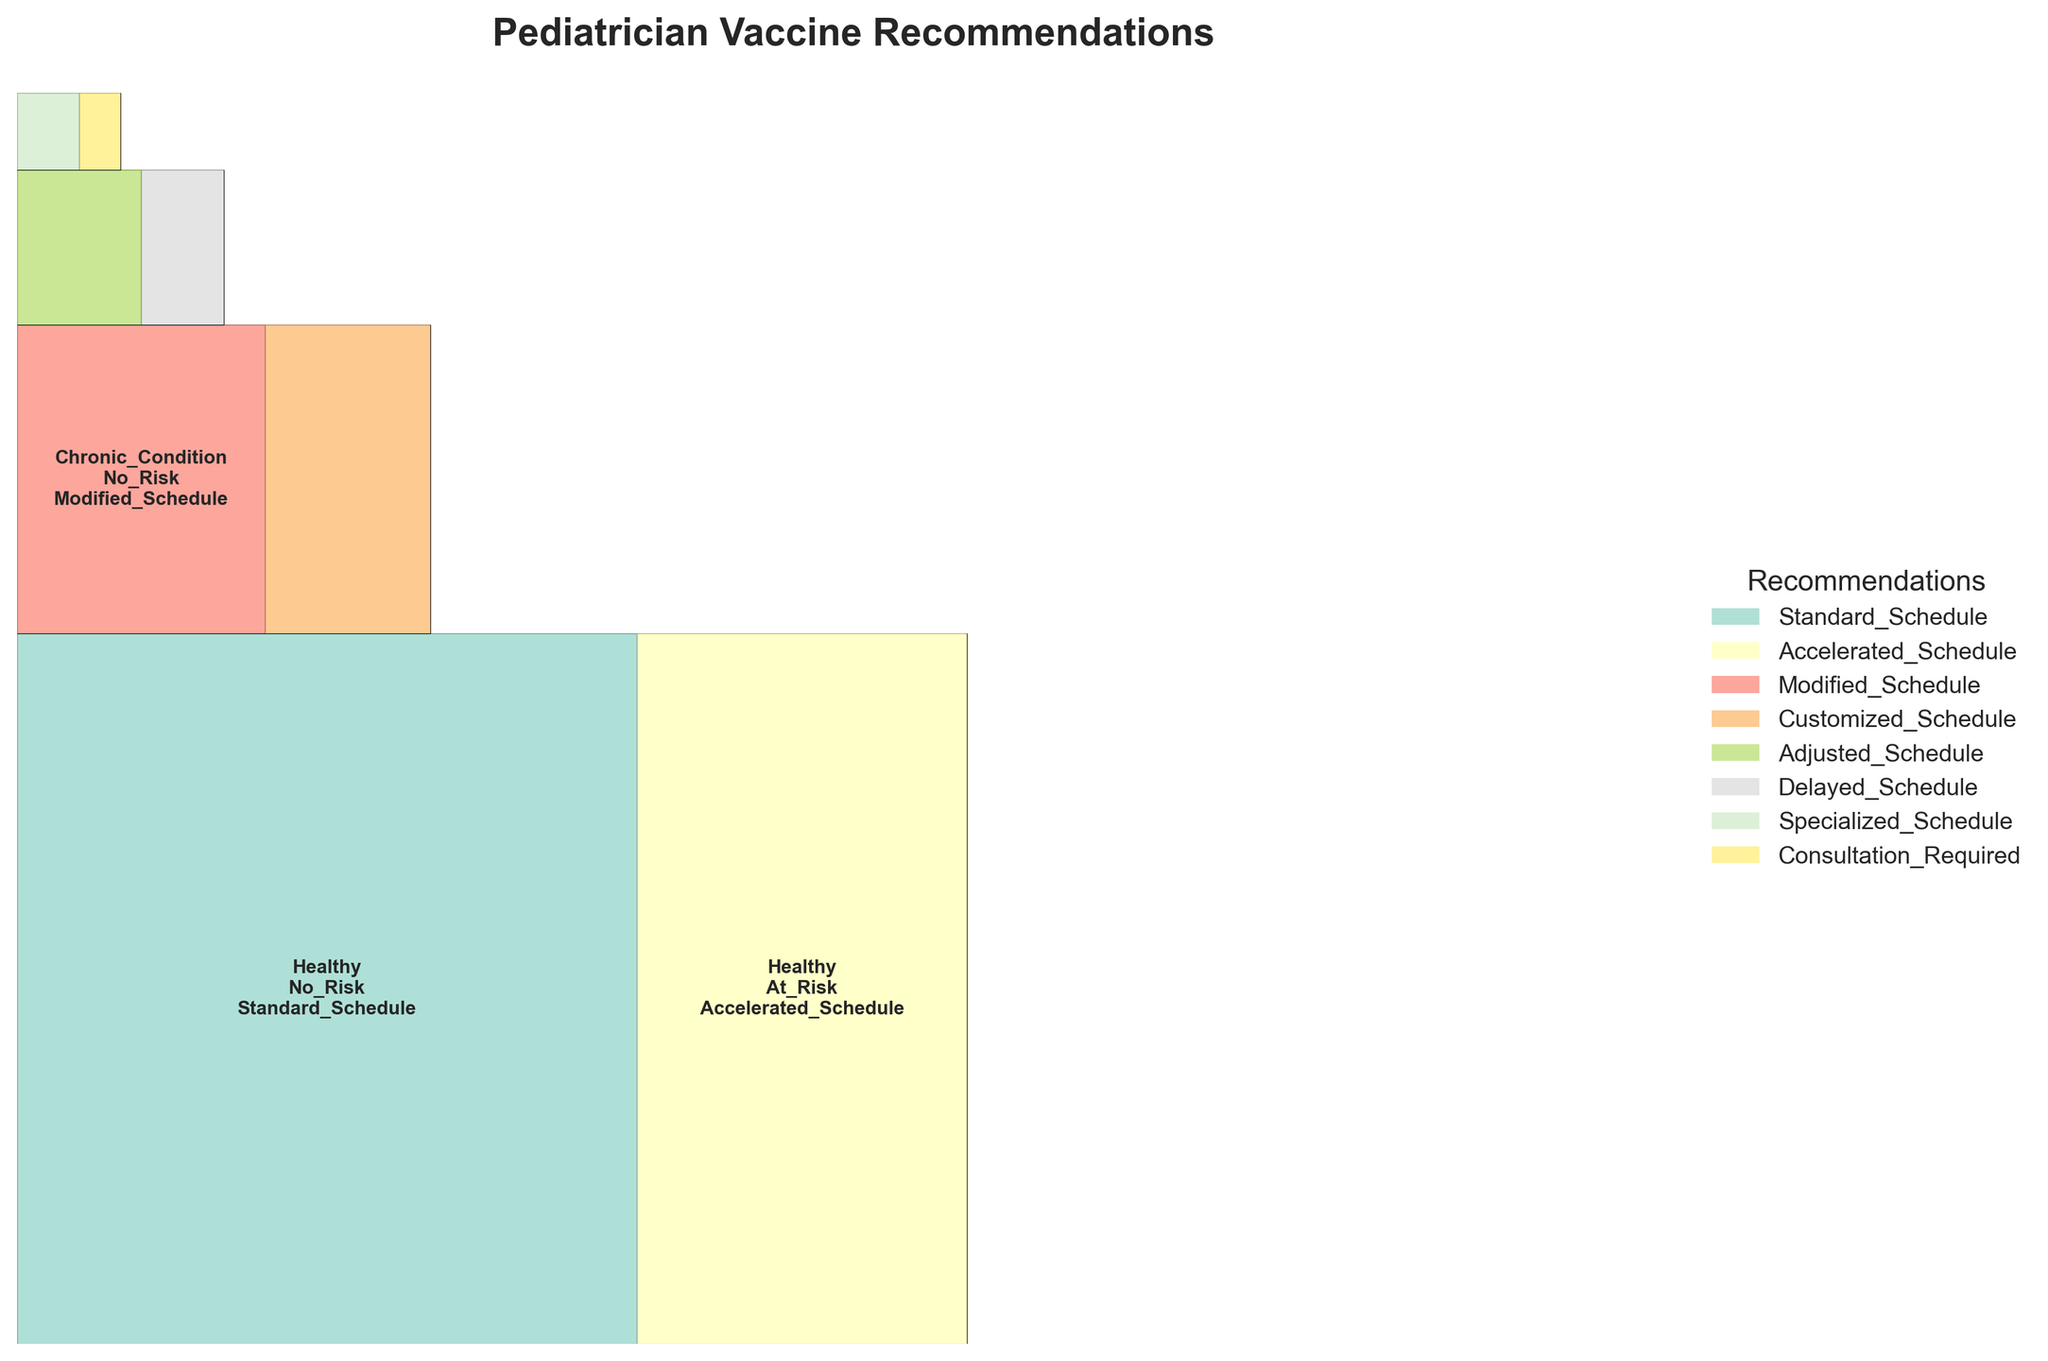What is the title of the plot? The title is usually located at the top of the figure, often in a bold font to stand out. In this case, it should clearly reflect the content of the plot.
Answer: Pediatrician Vaccine Recommendations How many different health statuses are represented in the plot? You can determine this by counting the unique health status categories listed in the labels within the rectangles in the plot.
Answer: 4 Which recommendation is suggested the most for healthy children with no family risk? Look for the rectangle labeled "Healthy" and "No_Risk," and observe the text inside it which indicates the recommendation.
Answer: Standard_Schedule What is the total proportion of recommendations for children with a chronic condition? Sum the proportions of the rectangles labeled "Chronic_Condition," both for "No_Risk" and "At_Risk" family history.
Answer: 0.20 How many family history categories are there? Count the unique family history categories labeled within the rectangles in the plot.
Answer: 2 Which group has the smallest number of recommendations? Identify the smallest rectangle in the plot, which correlates with the group having the smallest proportion. Check the label of that rectangle.
Answer: Immunocompromised, At_Risk, Consultation_Required What is the difference in the proportions of recommendations between healthy children at risk and those with a chronic condition at risk? Calculate the proportion for "Healthy" and "At_Risk" and "Chronic_Condition" and "At_Risk", and find their difference.
Answer: 0.10 (0.20 - 0.10) Which recommendation is given to both healthy children and those with chronic conditions but who have no family risk? Look at the rectangles for both "Healthy" and "Chronic_Condition" with "No_Risk," and check if they have the same recommendation.
Answer: No Are there more recommendations for children with no family risk or those with a family risk? Sum the proportions for rectangles under "No_Risk" and "At_Risk" and compare them.
Answer: No_Risk 